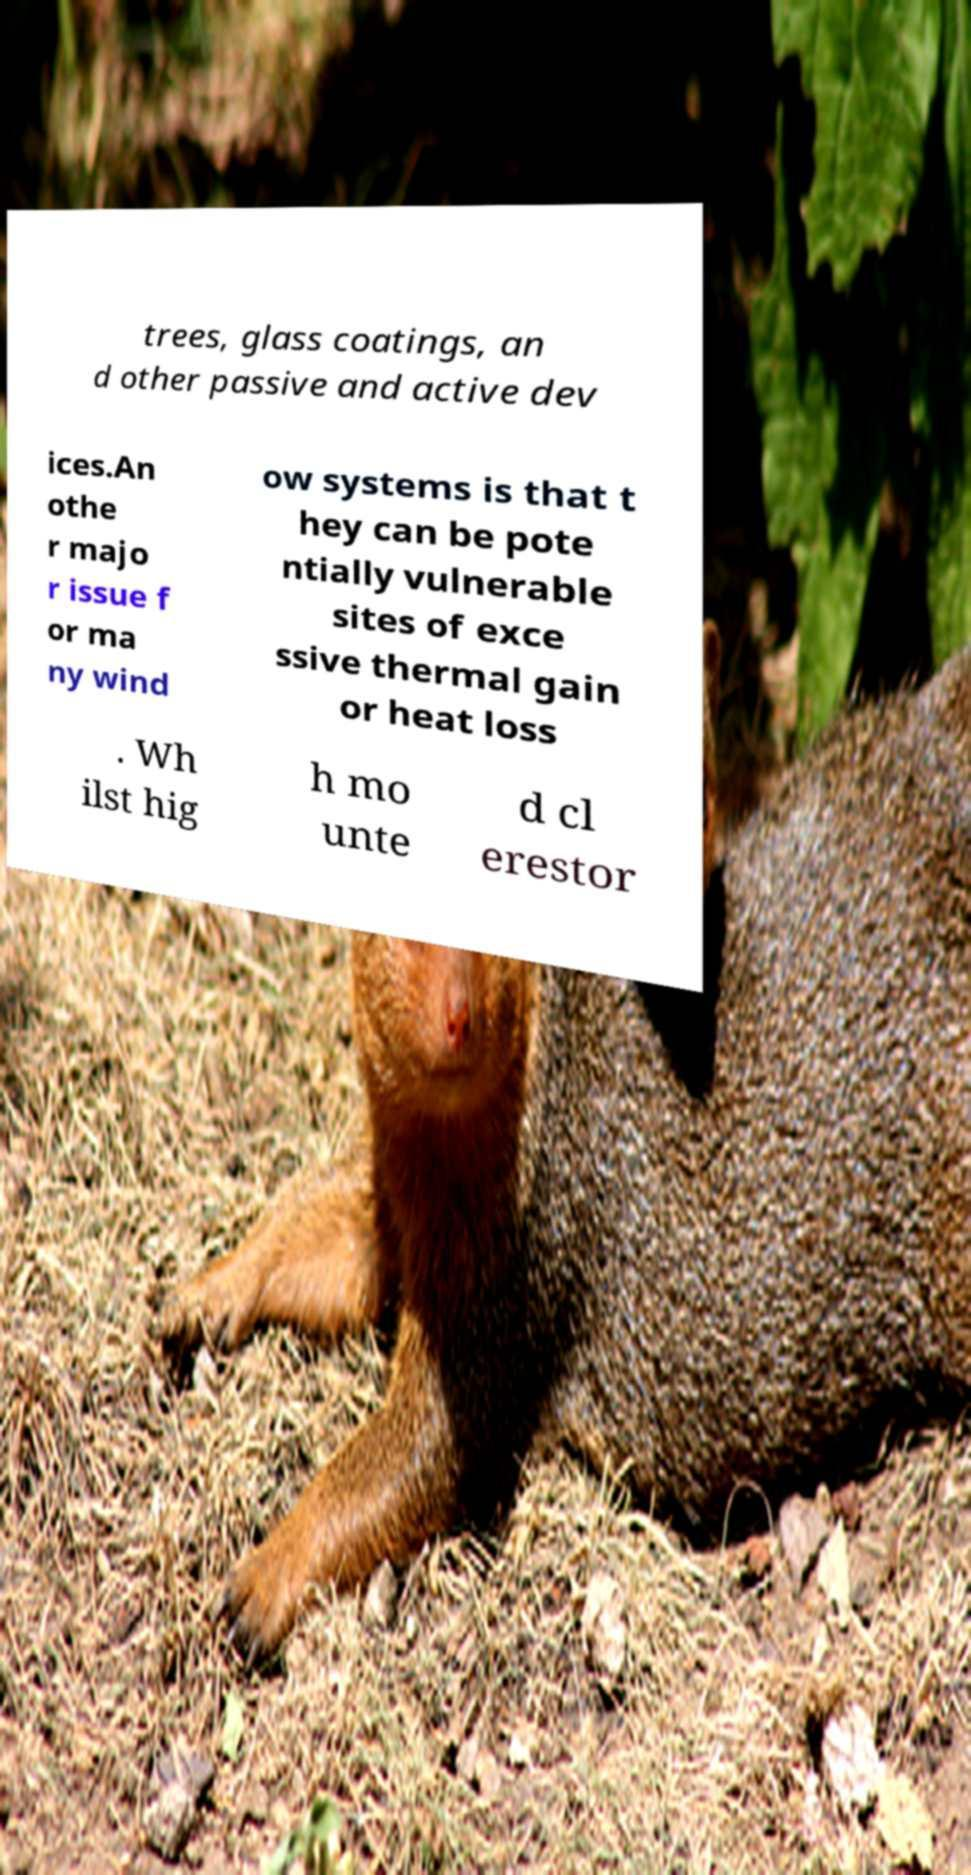Please identify and transcribe the text found in this image. trees, glass coatings, an d other passive and active dev ices.An othe r majo r issue f or ma ny wind ow systems is that t hey can be pote ntially vulnerable sites of exce ssive thermal gain or heat loss . Wh ilst hig h mo unte d cl erestor 